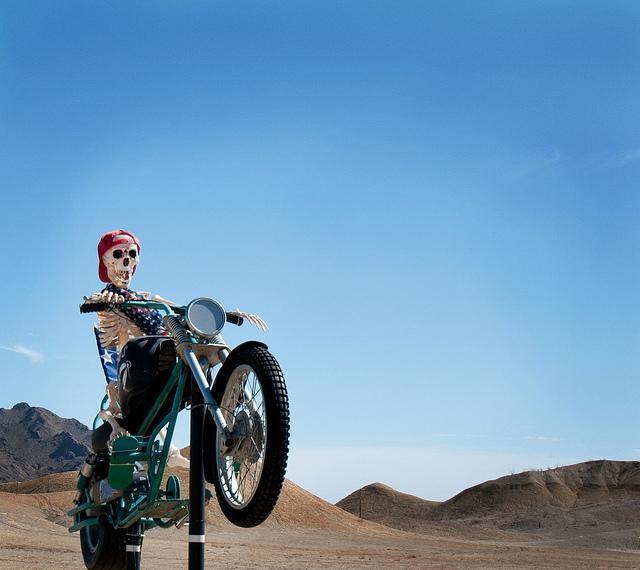How many motorcycles are there?
Give a very brief answer. 1. 